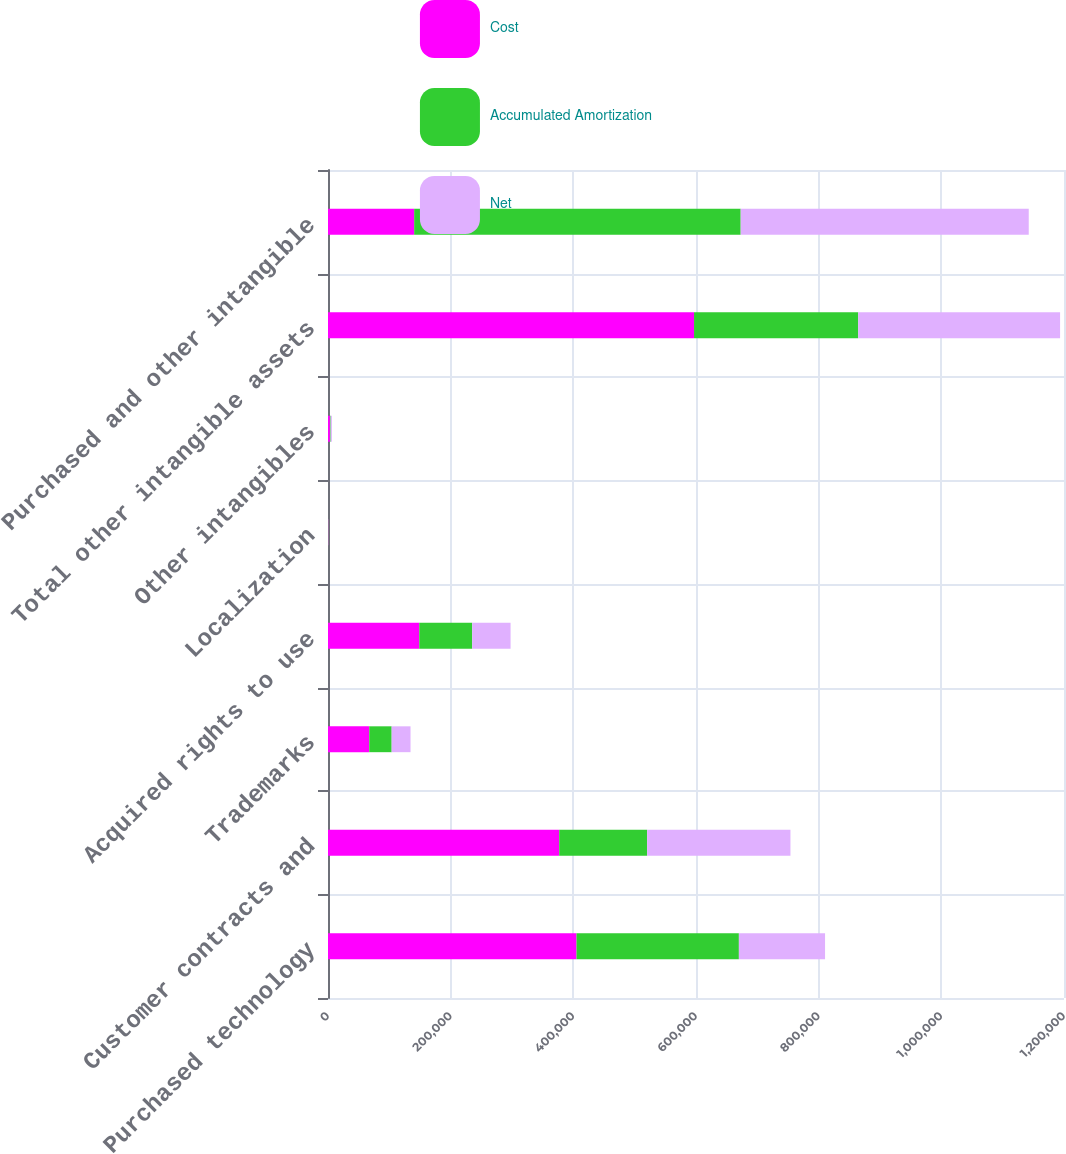Convert chart to OTSL. <chart><loc_0><loc_0><loc_500><loc_500><stacked_bar_chart><ecel><fcel>Purchased technology<fcel>Customer contracts and<fcel>Trademarks<fcel>Acquired rights to use<fcel>Localization<fcel>Other intangibles<fcel>Total other intangible assets<fcel>Purchased and other intangible<nl><fcel>Cost<fcel>405208<fcel>376994<fcel>67268<fcel>148836<fcel>549<fcel>3163<fcel>596810<fcel>140511<nl><fcel>Accumulated Amortization<fcel>264697<fcel>143330<fcel>36516<fcel>86258<fcel>382<fcel>1173<fcel>267659<fcel>532356<nl><fcel>Net<fcel>140511<fcel>233664<fcel>30752<fcel>62578<fcel>167<fcel>1990<fcel>329151<fcel>469662<nl></chart> 